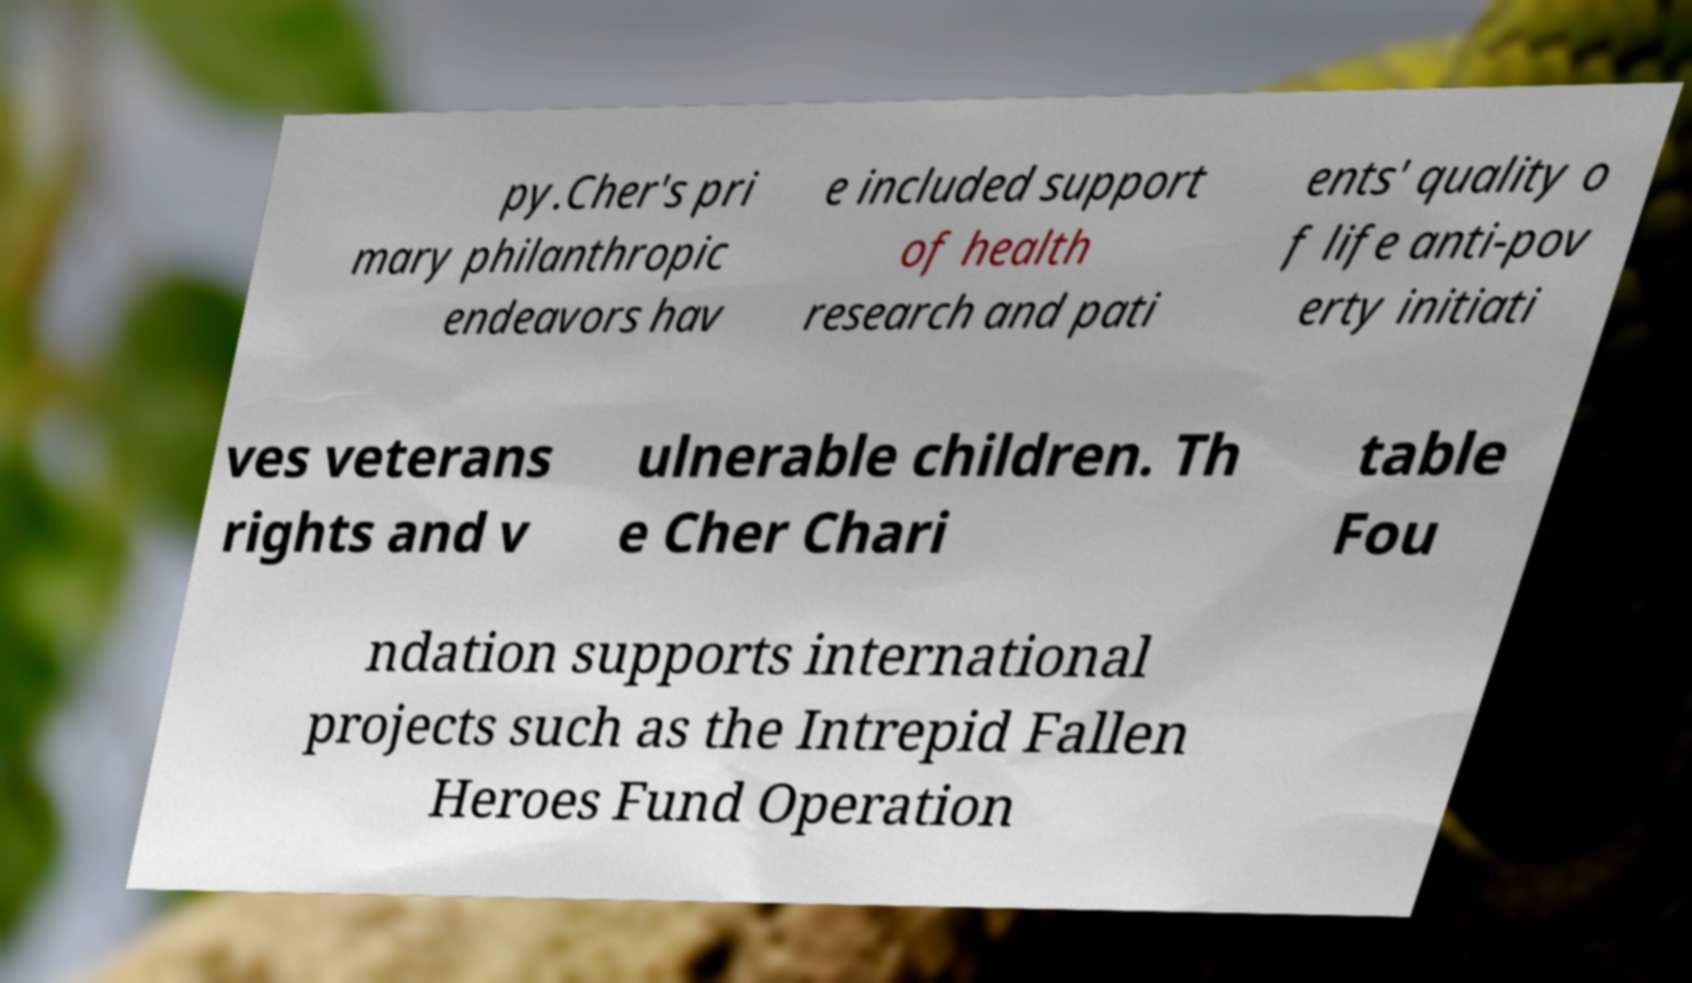Please identify and transcribe the text found in this image. py.Cher's pri mary philanthropic endeavors hav e included support of health research and pati ents' quality o f life anti-pov erty initiati ves veterans rights and v ulnerable children. Th e Cher Chari table Fou ndation supports international projects such as the Intrepid Fallen Heroes Fund Operation 